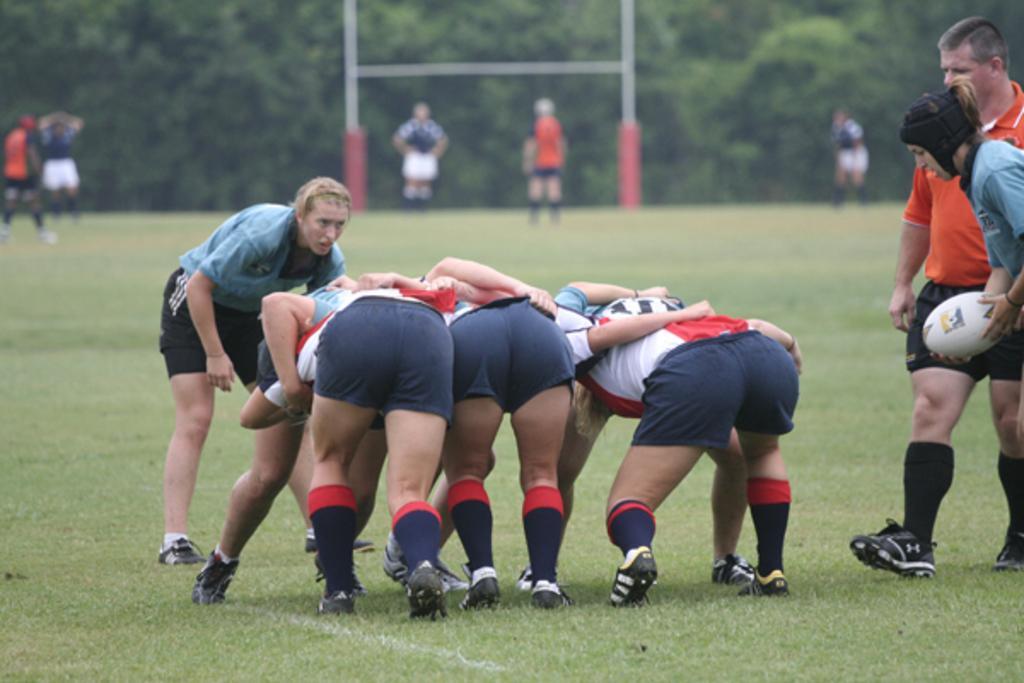Please provide a concise description of this image. In this image few persons are playing on the grass land. Right side a person is walking on the grassland. Before him there is a person holding a ball. Few persons are standing on the grassland. There are metal rods on the grassland. Background there are few trees. 